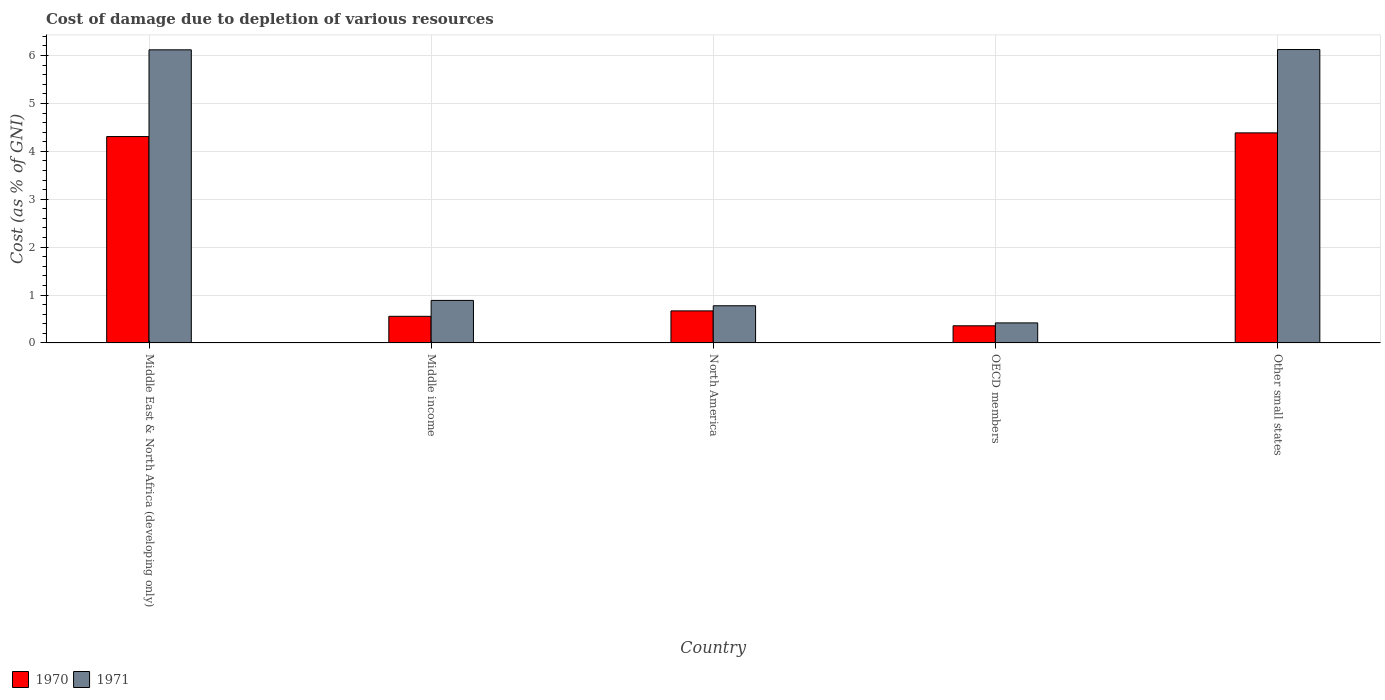How many different coloured bars are there?
Provide a short and direct response. 2. How many groups of bars are there?
Ensure brevity in your answer.  5. Are the number of bars per tick equal to the number of legend labels?
Make the answer very short. Yes. How many bars are there on the 5th tick from the left?
Offer a terse response. 2. How many bars are there on the 1st tick from the right?
Provide a succinct answer. 2. What is the label of the 4th group of bars from the left?
Offer a very short reply. OECD members. What is the cost of damage caused due to the depletion of various resources in 1970 in North America?
Offer a terse response. 0.67. Across all countries, what is the maximum cost of damage caused due to the depletion of various resources in 1971?
Your answer should be compact. 6.13. Across all countries, what is the minimum cost of damage caused due to the depletion of various resources in 1971?
Offer a very short reply. 0.42. In which country was the cost of damage caused due to the depletion of various resources in 1971 maximum?
Offer a very short reply. Other small states. What is the total cost of damage caused due to the depletion of various resources in 1971 in the graph?
Your answer should be compact. 14.33. What is the difference between the cost of damage caused due to the depletion of various resources in 1970 in Middle East & North Africa (developing only) and that in North America?
Provide a short and direct response. 3.64. What is the difference between the cost of damage caused due to the depletion of various resources in 1971 in Other small states and the cost of damage caused due to the depletion of various resources in 1970 in North America?
Give a very brief answer. 5.46. What is the average cost of damage caused due to the depletion of various resources in 1970 per country?
Provide a succinct answer. 2.06. What is the difference between the cost of damage caused due to the depletion of various resources of/in 1971 and cost of damage caused due to the depletion of various resources of/in 1970 in North America?
Ensure brevity in your answer.  0.11. In how many countries, is the cost of damage caused due to the depletion of various resources in 1971 greater than 1.6 %?
Your answer should be compact. 2. What is the ratio of the cost of damage caused due to the depletion of various resources in 1971 in OECD members to that in Other small states?
Offer a terse response. 0.07. What is the difference between the highest and the second highest cost of damage caused due to the depletion of various resources in 1971?
Your response must be concise. -5.24. What is the difference between the highest and the lowest cost of damage caused due to the depletion of various resources in 1971?
Provide a succinct answer. 5.71. In how many countries, is the cost of damage caused due to the depletion of various resources in 1971 greater than the average cost of damage caused due to the depletion of various resources in 1971 taken over all countries?
Your answer should be compact. 2. Is the sum of the cost of damage caused due to the depletion of various resources in 1971 in Middle East & North Africa (developing only) and North America greater than the maximum cost of damage caused due to the depletion of various resources in 1970 across all countries?
Ensure brevity in your answer.  Yes. What does the 1st bar from the left in OECD members represents?
Your answer should be compact. 1970. Are all the bars in the graph horizontal?
Keep it short and to the point. No. How many countries are there in the graph?
Provide a succinct answer. 5. What is the difference between two consecutive major ticks on the Y-axis?
Provide a short and direct response. 1. Are the values on the major ticks of Y-axis written in scientific E-notation?
Your answer should be compact. No. Does the graph contain any zero values?
Ensure brevity in your answer.  No. What is the title of the graph?
Make the answer very short. Cost of damage due to depletion of various resources. Does "1978" appear as one of the legend labels in the graph?
Make the answer very short. No. What is the label or title of the X-axis?
Provide a succinct answer. Country. What is the label or title of the Y-axis?
Your answer should be very brief. Cost (as % of GNI). What is the Cost (as % of GNI) in 1970 in Middle East & North Africa (developing only)?
Make the answer very short. 4.31. What is the Cost (as % of GNI) in 1971 in Middle East & North Africa (developing only)?
Provide a short and direct response. 6.12. What is the Cost (as % of GNI) in 1970 in Middle income?
Your response must be concise. 0.56. What is the Cost (as % of GNI) in 1971 in Middle income?
Offer a terse response. 0.89. What is the Cost (as % of GNI) in 1970 in North America?
Provide a short and direct response. 0.67. What is the Cost (as % of GNI) of 1971 in North America?
Ensure brevity in your answer.  0.78. What is the Cost (as % of GNI) of 1970 in OECD members?
Give a very brief answer. 0.36. What is the Cost (as % of GNI) of 1971 in OECD members?
Ensure brevity in your answer.  0.42. What is the Cost (as % of GNI) of 1970 in Other small states?
Make the answer very short. 4.39. What is the Cost (as % of GNI) of 1971 in Other small states?
Your response must be concise. 6.13. Across all countries, what is the maximum Cost (as % of GNI) in 1970?
Your answer should be compact. 4.39. Across all countries, what is the maximum Cost (as % of GNI) in 1971?
Ensure brevity in your answer.  6.13. Across all countries, what is the minimum Cost (as % of GNI) in 1970?
Provide a succinct answer. 0.36. Across all countries, what is the minimum Cost (as % of GNI) in 1971?
Give a very brief answer. 0.42. What is the total Cost (as % of GNI) in 1970 in the graph?
Keep it short and to the point. 10.28. What is the total Cost (as % of GNI) of 1971 in the graph?
Your response must be concise. 14.33. What is the difference between the Cost (as % of GNI) of 1970 in Middle East & North Africa (developing only) and that in Middle income?
Your answer should be compact. 3.75. What is the difference between the Cost (as % of GNI) in 1971 in Middle East & North Africa (developing only) and that in Middle income?
Provide a short and direct response. 5.23. What is the difference between the Cost (as % of GNI) of 1970 in Middle East & North Africa (developing only) and that in North America?
Provide a short and direct response. 3.64. What is the difference between the Cost (as % of GNI) of 1971 in Middle East & North Africa (developing only) and that in North America?
Ensure brevity in your answer.  5.34. What is the difference between the Cost (as % of GNI) of 1970 in Middle East & North Africa (developing only) and that in OECD members?
Provide a short and direct response. 3.95. What is the difference between the Cost (as % of GNI) of 1971 in Middle East & North Africa (developing only) and that in OECD members?
Provide a succinct answer. 5.7. What is the difference between the Cost (as % of GNI) of 1970 in Middle East & North Africa (developing only) and that in Other small states?
Ensure brevity in your answer.  -0.08. What is the difference between the Cost (as % of GNI) of 1971 in Middle East & North Africa (developing only) and that in Other small states?
Provide a succinct answer. -0.01. What is the difference between the Cost (as % of GNI) of 1970 in Middle income and that in North America?
Your answer should be very brief. -0.11. What is the difference between the Cost (as % of GNI) of 1971 in Middle income and that in North America?
Make the answer very short. 0.11. What is the difference between the Cost (as % of GNI) in 1970 in Middle income and that in OECD members?
Give a very brief answer. 0.2. What is the difference between the Cost (as % of GNI) of 1971 in Middle income and that in OECD members?
Keep it short and to the point. 0.47. What is the difference between the Cost (as % of GNI) in 1970 in Middle income and that in Other small states?
Give a very brief answer. -3.83. What is the difference between the Cost (as % of GNI) of 1971 in Middle income and that in Other small states?
Ensure brevity in your answer.  -5.24. What is the difference between the Cost (as % of GNI) of 1970 in North America and that in OECD members?
Offer a terse response. 0.31. What is the difference between the Cost (as % of GNI) in 1971 in North America and that in OECD members?
Ensure brevity in your answer.  0.36. What is the difference between the Cost (as % of GNI) of 1970 in North America and that in Other small states?
Your answer should be compact. -3.72. What is the difference between the Cost (as % of GNI) of 1971 in North America and that in Other small states?
Your answer should be very brief. -5.35. What is the difference between the Cost (as % of GNI) of 1970 in OECD members and that in Other small states?
Make the answer very short. -4.03. What is the difference between the Cost (as % of GNI) in 1971 in OECD members and that in Other small states?
Provide a succinct answer. -5.71. What is the difference between the Cost (as % of GNI) in 1970 in Middle East & North Africa (developing only) and the Cost (as % of GNI) in 1971 in Middle income?
Your response must be concise. 3.42. What is the difference between the Cost (as % of GNI) of 1970 in Middle East & North Africa (developing only) and the Cost (as % of GNI) of 1971 in North America?
Keep it short and to the point. 3.53. What is the difference between the Cost (as % of GNI) in 1970 in Middle East & North Africa (developing only) and the Cost (as % of GNI) in 1971 in OECD members?
Offer a very short reply. 3.89. What is the difference between the Cost (as % of GNI) in 1970 in Middle East & North Africa (developing only) and the Cost (as % of GNI) in 1971 in Other small states?
Make the answer very short. -1.82. What is the difference between the Cost (as % of GNI) of 1970 in Middle income and the Cost (as % of GNI) of 1971 in North America?
Offer a terse response. -0.22. What is the difference between the Cost (as % of GNI) of 1970 in Middle income and the Cost (as % of GNI) of 1971 in OECD members?
Keep it short and to the point. 0.14. What is the difference between the Cost (as % of GNI) of 1970 in Middle income and the Cost (as % of GNI) of 1971 in Other small states?
Offer a terse response. -5.57. What is the difference between the Cost (as % of GNI) of 1970 in North America and the Cost (as % of GNI) of 1971 in OECD members?
Your response must be concise. 0.25. What is the difference between the Cost (as % of GNI) in 1970 in North America and the Cost (as % of GNI) in 1971 in Other small states?
Make the answer very short. -5.46. What is the difference between the Cost (as % of GNI) in 1970 in OECD members and the Cost (as % of GNI) in 1971 in Other small states?
Your response must be concise. -5.77. What is the average Cost (as % of GNI) in 1970 per country?
Make the answer very short. 2.06. What is the average Cost (as % of GNI) in 1971 per country?
Give a very brief answer. 2.87. What is the difference between the Cost (as % of GNI) in 1970 and Cost (as % of GNI) in 1971 in Middle East & North Africa (developing only)?
Your answer should be very brief. -1.81. What is the difference between the Cost (as % of GNI) of 1970 and Cost (as % of GNI) of 1971 in Middle income?
Keep it short and to the point. -0.33. What is the difference between the Cost (as % of GNI) in 1970 and Cost (as % of GNI) in 1971 in North America?
Your answer should be very brief. -0.11. What is the difference between the Cost (as % of GNI) in 1970 and Cost (as % of GNI) in 1971 in OECD members?
Give a very brief answer. -0.06. What is the difference between the Cost (as % of GNI) in 1970 and Cost (as % of GNI) in 1971 in Other small states?
Give a very brief answer. -1.74. What is the ratio of the Cost (as % of GNI) in 1970 in Middle East & North Africa (developing only) to that in Middle income?
Provide a short and direct response. 7.76. What is the ratio of the Cost (as % of GNI) in 1971 in Middle East & North Africa (developing only) to that in Middle income?
Provide a succinct answer. 6.89. What is the ratio of the Cost (as % of GNI) of 1970 in Middle East & North Africa (developing only) to that in North America?
Make the answer very short. 6.44. What is the ratio of the Cost (as % of GNI) of 1971 in Middle East & North Africa (developing only) to that in North America?
Your answer should be very brief. 7.88. What is the ratio of the Cost (as % of GNI) in 1970 in Middle East & North Africa (developing only) to that in OECD members?
Your response must be concise. 12.03. What is the ratio of the Cost (as % of GNI) of 1971 in Middle East & North Africa (developing only) to that in OECD members?
Offer a very short reply. 14.62. What is the ratio of the Cost (as % of GNI) of 1970 in Middle East & North Africa (developing only) to that in Other small states?
Your response must be concise. 0.98. What is the ratio of the Cost (as % of GNI) of 1971 in Middle East & North Africa (developing only) to that in Other small states?
Give a very brief answer. 1. What is the ratio of the Cost (as % of GNI) of 1970 in Middle income to that in North America?
Ensure brevity in your answer.  0.83. What is the ratio of the Cost (as % of GNI) of 1971 in Middle income to that in North America?
Give a very brief answer. 1.14. What is the ratio of the Cost (as % of GNI) in 1970 in Middle income to that in OECD members?
Make the answer very short. 1.55. What is the ratio of the Cost (as % of GNI) of 1971 in Middle income to that in OECD members?
Provide a short and direct response. 2.12. What is the ratio of the Cost (as % of GNI) of 1970 in Middle income to that in Other small states?
Provide a short and direct response. 0.13. What is the ratio of the Cost (as % of GNI) in 1971 in Middle income to that in Other small states?
Give a very brief answer. 0.14. What is the ratio of the Cost (as % of GNI) in 1970 in North America to that in OECD members?
Offer a very short reply. 1.87. What is the ratio of the Cost (as % of GNI) of 1971 in North America to that in OECD members?
Ensure brevity in your answer.  1.85. What is the ratio of the Cost (as % of GNI) of 1970 in North America to that in Other small states?
Your answer should be compact. 0.15. What is the ratio of the Cost (as % of GNI) in 1971 in North America to that in Other small states?
Offer a very short reply. 0.13. What is the ratio of the Cost (as % of GNI) in 1970 in OECD members to that in Other small states?
Offer a very short reply. 0.08. What is the ratio of the Cost (as % of GNI) in 1971 in OECD members to that in Other small states?
Offer a very short reply. 0.07. What is the difference between the highest and the second highest Cost (as % of GNI) in 1970?
Provide a short and direct response. 0.08. What is the difference between the highest and the second highest Cost (as % of GNI) in 1971?
Offer a very short reply. 0.01. What is the difference between the highest and the lowest Cost (as % of GNI) of 1970?
Your answer should be compact. 4.03. What is the difference between the highest and the lowest Cost (as % of GNI) of 1971?
Your answer should be compact. 5.71. 